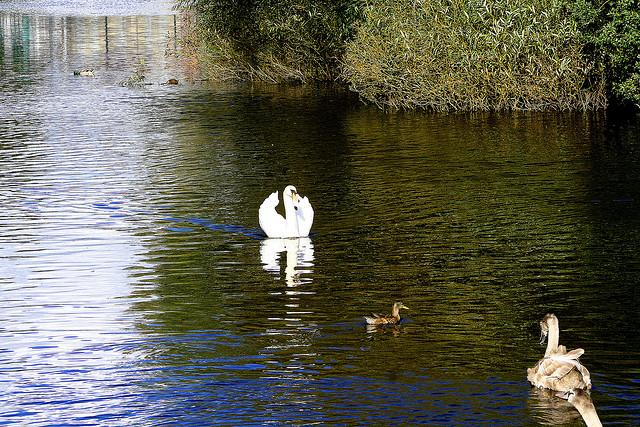What is the smaller bird in between the two larger birds? duck 